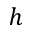Convert formula to latex. <formula><loc_0><loc_0><loc_500><loc_500>h</formula> 